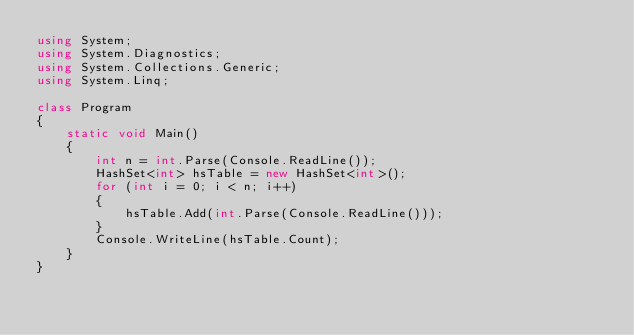<code> <loc_0><loc_0><loc_500><loc_500><_C#_>using System;
using System.Diagnostics;
using System.Collections.Generic;
using System.Linq;

class Program
{
    static void Main()
    {
        int n = int.Parse(Console.ReadLine());
        HashSet<int> hsTable = new HashSet<int>();
        for (int i = 0; i < n; i++)
        {
            hsTable.Add(int.Parse(Console.ReadLine()));
        }
        Console.WriteLine(hsTable.Count);
    }
}</code> 